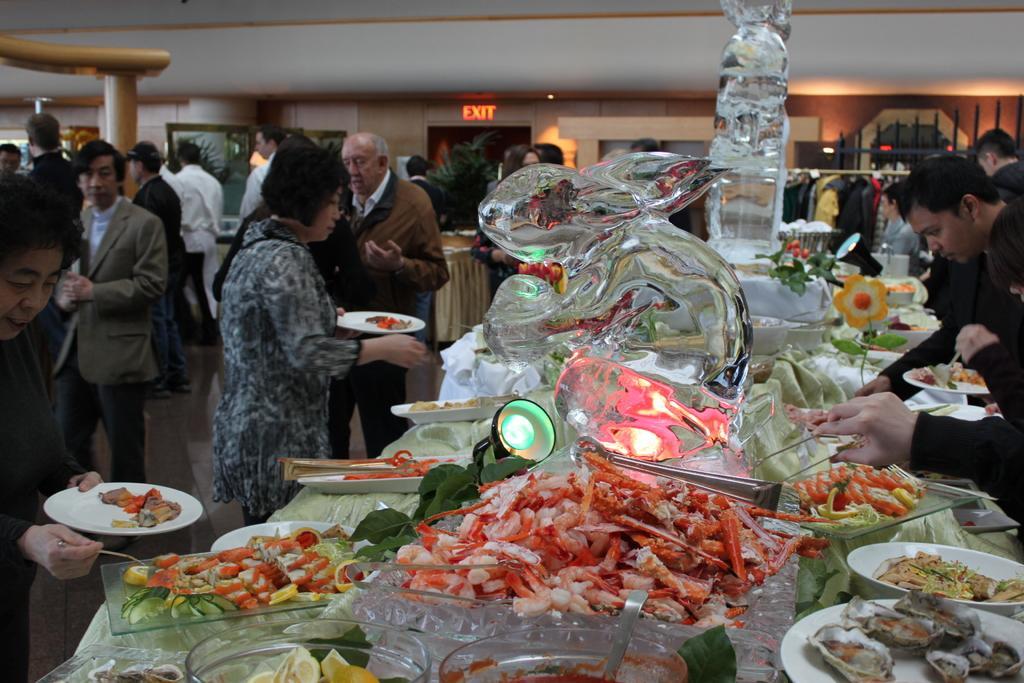How would you summarize this image in a sentence or two? In the middle it is a glass in the shape of a rabbit, these are the food items. On the left side few persons are standing. 